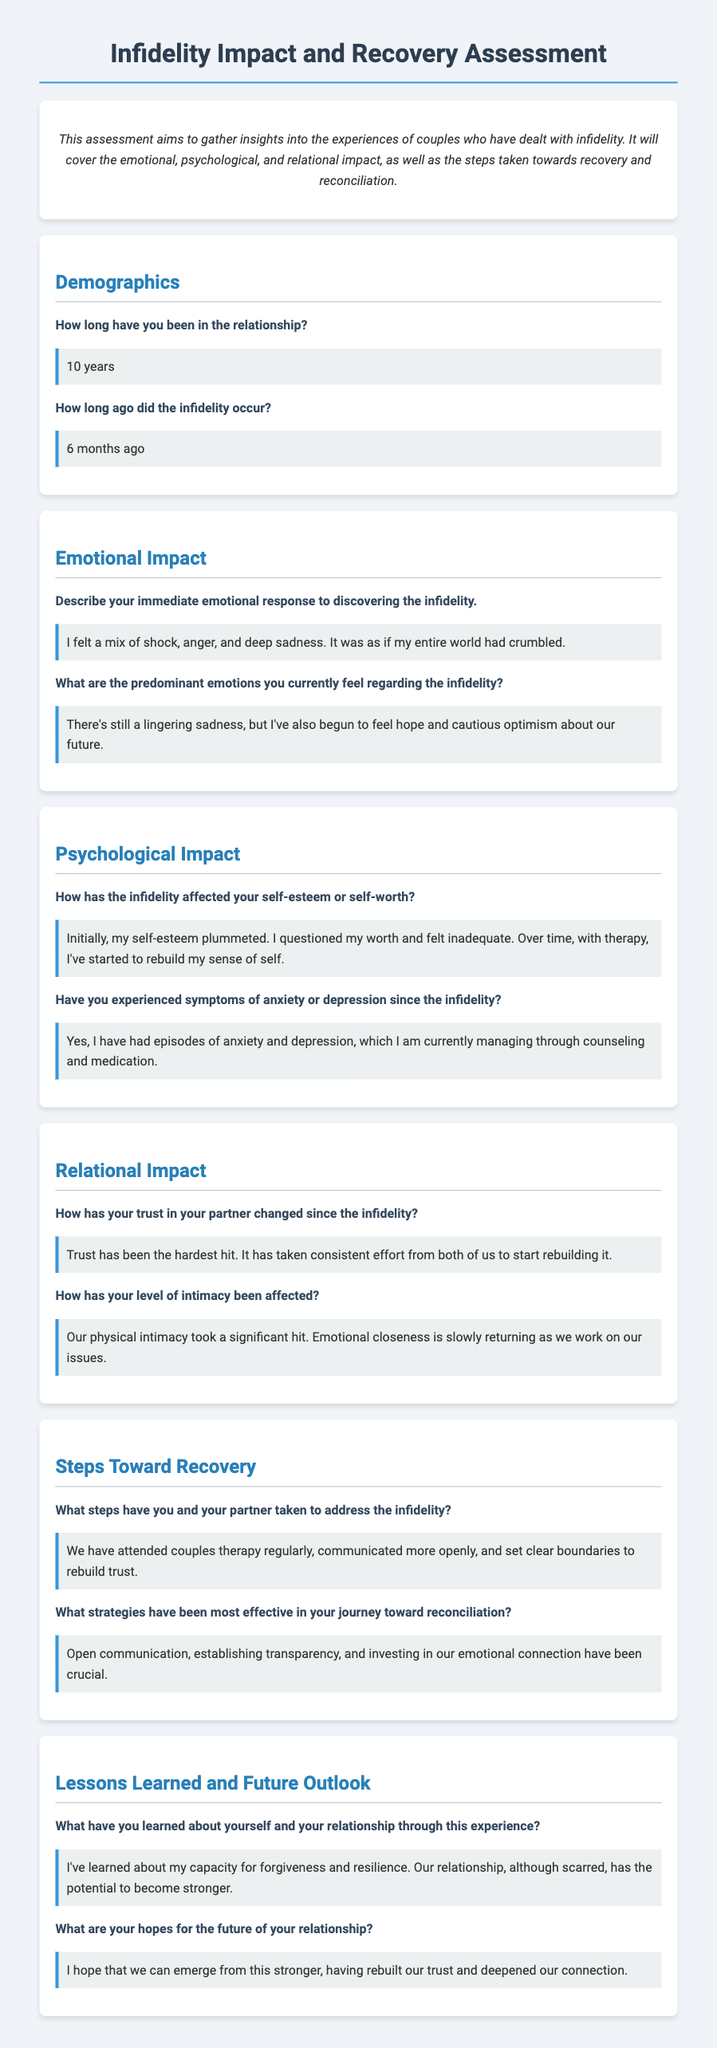How long have you been in the relationship? This question is asking for the duration of the relationship as stated in the demographics section.
Answer: 10 years How long ago did the infidelity occur? This question requires the time frame since the infidelity incident based on the demographic data provided.
Answer: 6 months ago What was the immediate emotional response to discovering the infidelity? This question seeks to retrieve the specific emotional reaction described in the emotional impact section.
Answer: I felt a mix of shock, anger, and deep sadness What emotions are currently felt regarding the infidelity? This question combines insights into current emotional states related to the infidelity experience mentioned in the emotional impact section.
Answer: There's still a lingering sadness, but I've also begun to feel hope and cautious optimism about our future How has trust in the partner changed since the infidelity? This question examines the change in trust level as discussed in the relational impact section, requiring the respondent to summarize that information.
Answer: Trust has been the hardest hit What steps have been taken to address the infidelity? This question looks for specific actions taken by the couple to recover, as outlined in the steps toward recovery section.
Answer: We have attended couples therapy regularly, communicated more openly, and set clear boundaries to rebuild trust What strategies have been most effective in reconciliation? This question is focused on identifying key strategies that have worked during the recovery process from the document.
Answer: Open communication, establishing transparency, and investing in our emotional connection have been crucial What has been learned about oneself through this experience? This question asks for personal insights gained, based on the lessons learned and future outlook section.
Answer: I've learned about my capacity for forgiveness and resilience What are your hopes for the future of your relationship? This question seeks to summarize the respondent's future outlook as expressed in the lessons learned and future outlook section.
Answer: I hope that we can emerge from this stronger 